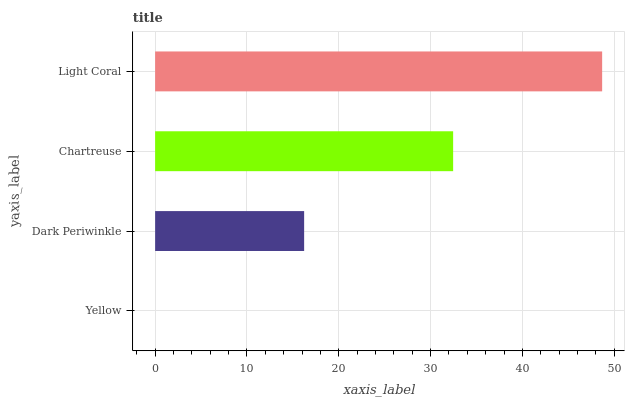Is Yellow the minimum?
Answer yes or no. Yes. Is Light Coral the maximum?
Answer yes or no. Yes. Is Dark Periwinkle the minimum?
Answer yes or no. No. Is Dark Periwinkle the maximum?
Answer yes or no. No. Is Dark Periwinkle greater than Yellow?
Answer yes or no. Yes. Is Yellow less than Dark Periwinkle?
Answer yes or no. Yes. Is Yellow greater than Dark Periwinkle?
Answer yes or no. No. Is Dark Periwinkle less than Yellow?
Answer yes or no. No. Is Chartreuse the high median?
Answer yes or no. Yes. Is Dark Periwinkle the low median?
Answer yes or no. Yes. Is Yellow the high median?
Answer yes or no. No. Is Chartreuse the low median?
Answer yes or no. No. 